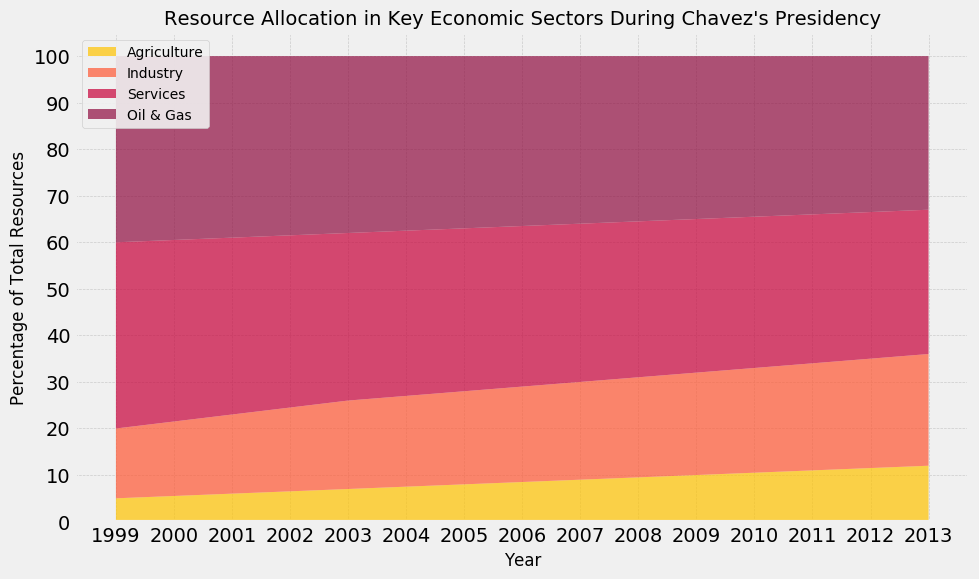What sector had the highest resource allocation in 1999? The sector with the highest resource allocation in 1999 can be identified by looking at the chart's stacked areas. In 1999, the 'Services' sector appears to have the highest allocation with 40%.
Answer: Services How did the percentage of resources allocated to Agriculture change from 1999 to 2013? To find this, look at the starting and ending values for the 'Agriculture' sector. In 1999, Agriculture had 5%, and by 2013, it had increased to 12%.
Answer: Increased by 7% Which sector had the largest increase in resource allocation percentage over Chavez's presidency? By examining the starting and ending values for each sector, 'Agriculture' rose from 5% to 12%, 'Industry' from 15% to 24%, 'Services' declined from 40% to 31%, and 'Oil & Gas' declined from 40% to 33%. The 'Industry' sector experienced the largest increase.
Answer: Industry What was the total percentage of resources allocated to 'Industry' and 'Oil & Gas' in 2007? Add the percentages of 'Industry' (21%) and 'Oil & Gas' (36%) for the year 2007.
Answer: 57% Did the 'Services' sector ever fall below 32%? If so, when? By observing the area allocated to 'Services,' it reaches 32% in 2011 and stays above that till then. From 2012, 'Services' fell to 31.5% in 2012, and again to 31% in 2013.
Answer: Yes, in 2012 and 2013 Which sector's area is represented by the color red? By visually examining the color coding in the area chart, the 'Services' sector is represented by the color red.
Answer: Services In what year did 'Agriculture' and 'Oil & Gas' have the same combined allocation as 'Services'? Compare the sums of 'Agriculture' and 'Oil & Gas' percentage with 'Services' for each year. In 2011, 'Agriculture' (11%) + 'Oil & Gas' (34%) equals 'Services' (32%).
Answer: 2011 What is the average resource allocation percentage across all sectors in the year 2005? Sum the resource allocations for 2005 (8%+20%+35%+37%) to get 100% and then divide by 4.
Answer: 25% Which sector showed a consistent increase in resource allocation every year? By following the trend lines, 'Agriculture' and 'Industry' show continuous yearly increases in their percentages, but 'Agriculture' is the only one that increases every year without exception.
Answer: Agriculture 